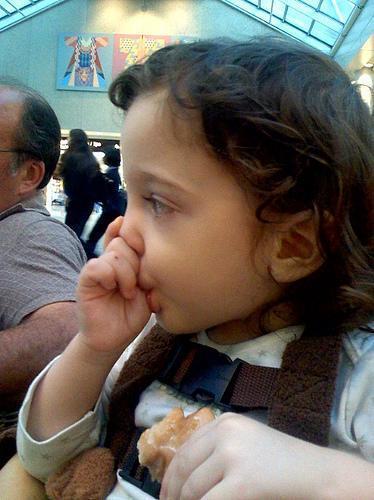How many people are there?
Give a very brief answer. 3. 